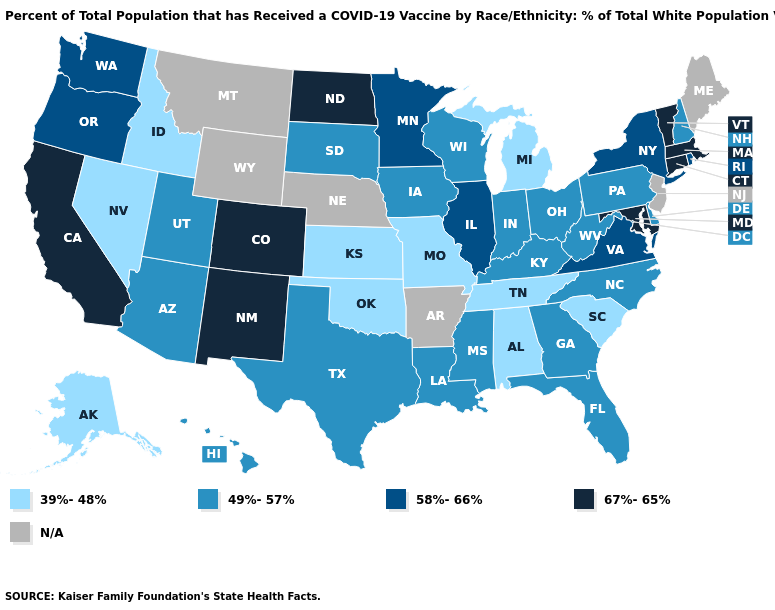What is the value of California?
Answer briefly. 67%-65%. Name the states that have a value in the range 58%-66%?
Be succinct. Illinois, Minnesota, New York, Oregon, Rhode Island, Virginia, Washington. Does Pennsylvania have the highest value in the Northeast?
Keep it brief. No. What is the value of Oregon?
Quick response, please. 58%-66%. What is the value of New York?
Concise answer only. 58%-66%. Does Alaska have the highest value in the USA?
Keep it brief. No. Name the states that have a value in the range 58%-66%?
Give a very brief answer. Illinois, Minnesota, New York, Oregon, Rhode Island, Virginia, Washington. Name the states that have a value in the range 67%-65%?
Be succinct. California, Colorado, Connecticut, Maryland, Massachusetts, New Mexico, North Dakota, Vermont. Name the states that have a value in the range 58%-66%?
Short answer required. Illinois, Minnesota, New York, Oregon, Rhode Island, Virginia, Washington. Which states have the lowest value in the USA?
Short answer required. Alabama, Alaska, Idaho, Kansas, Michigan, Missouri, Nevada, Oklahoma, South Carolina, Tennessee. Which states have the lowest value in the USA?
Keep it brief. Alabama, Alaska, Idaho, Kansas, Michigan, Missouri, Nevada, Oklahoma, South Carolina, Tennessee. What is the value of Illinois?
Quick response, please. 58%-66%. Among the states that border Vermont , does New Hampshire have the lowest value?
Concise answer only. Yes. What is the lowest value in the Northeast?
Answer briefly. 49%-57%. 